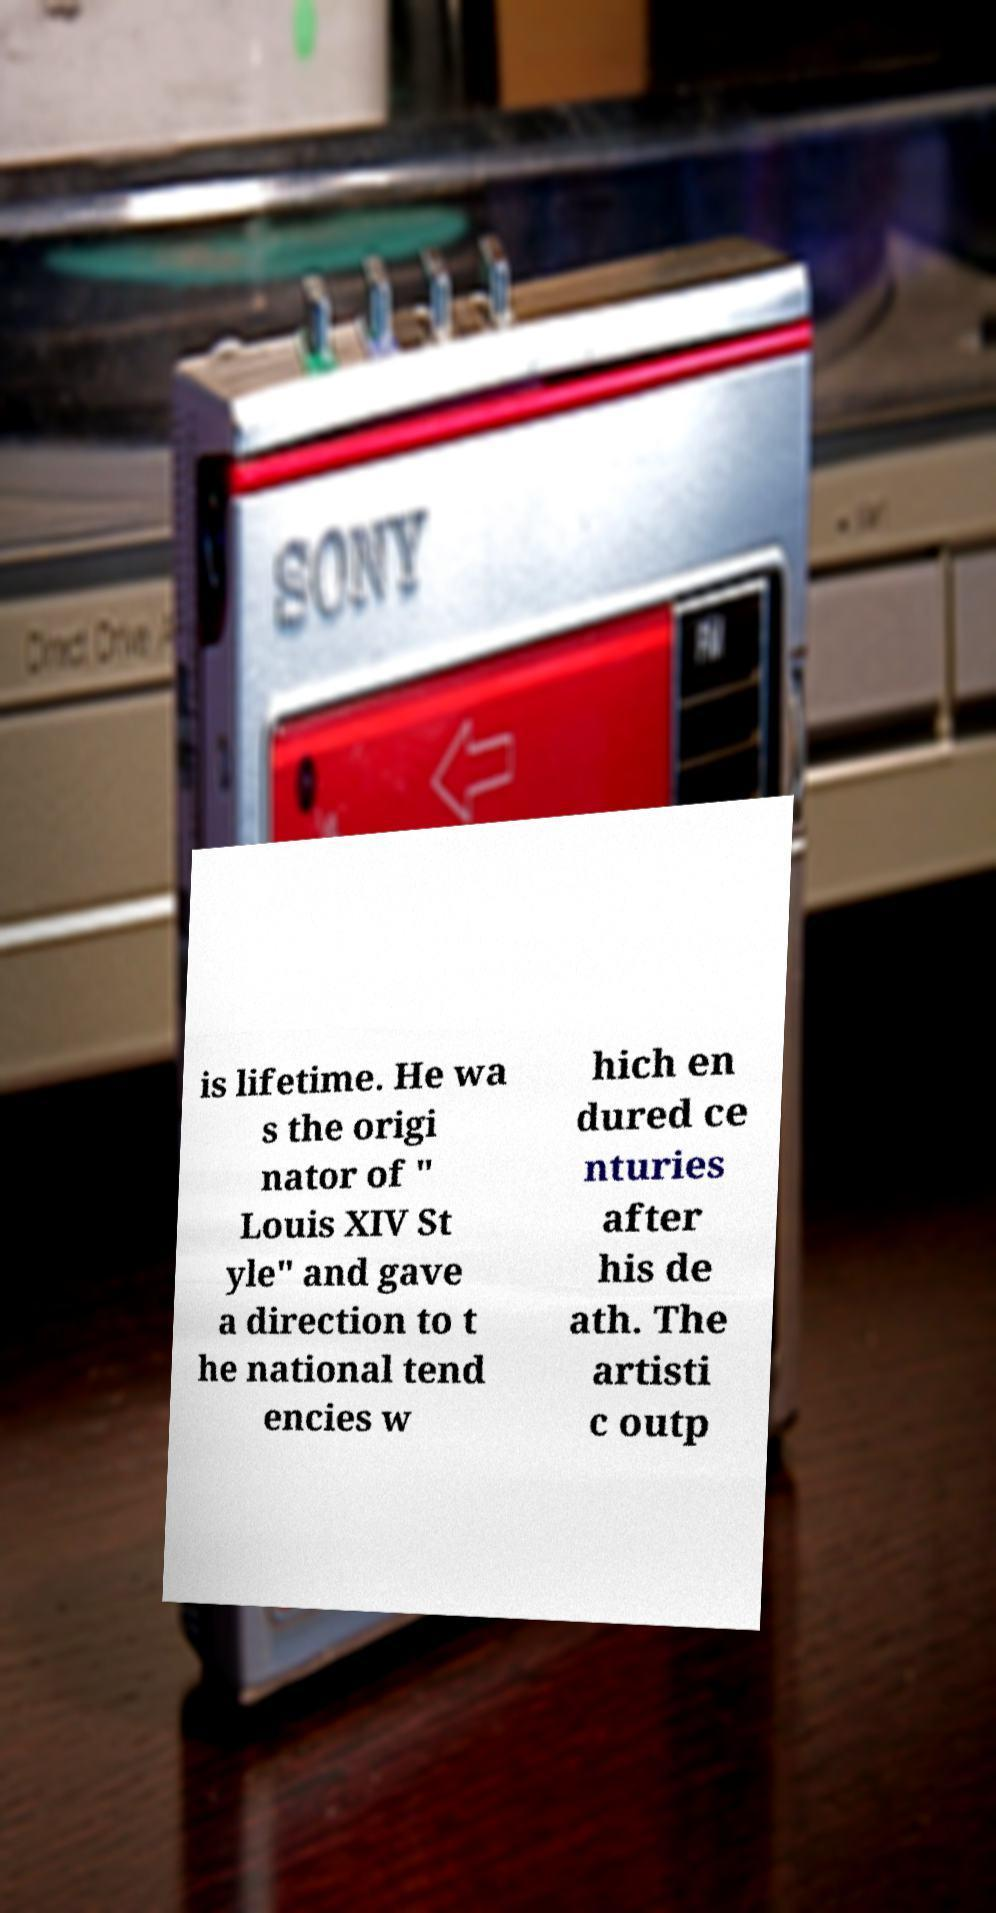Can you accurately transcribe the text from the provided image for me? is lifetime. He wa s the origi nator of " Louis XIV St yle" and gave a direction to t he national tend encies w hich en dured ce nturies after his de ath. The artisti c outp 